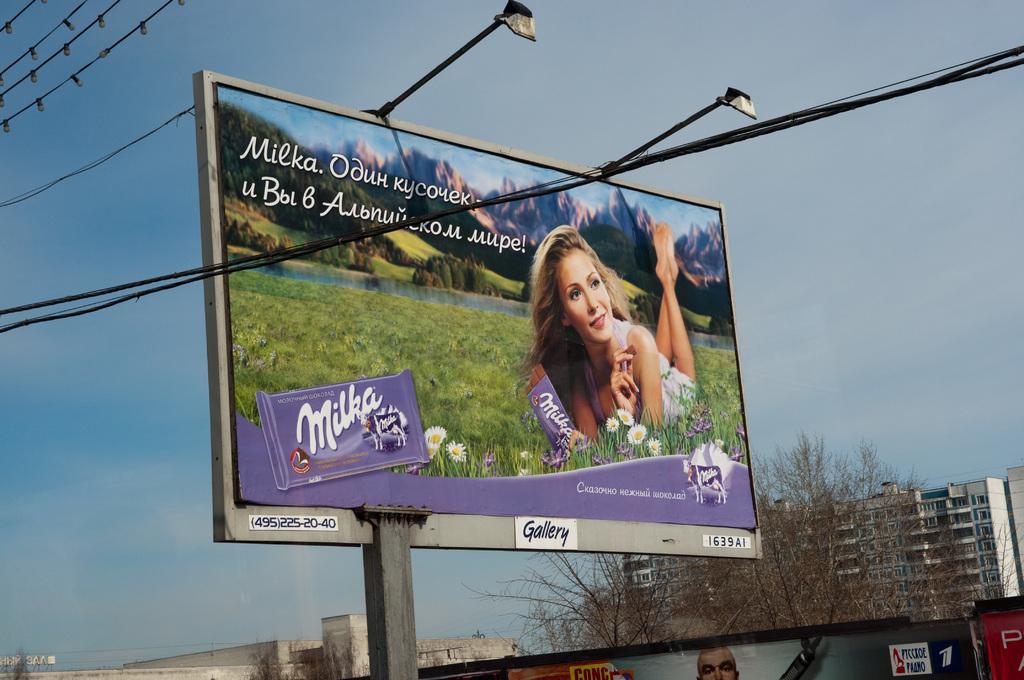Who owns the billboard?
Give a very brief answer. Gallery. What brand is advertised?
Provide a short and direct response. Milka. 